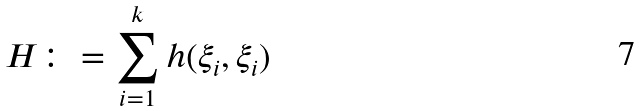<formula> <loc_0><loc_0><loc_500><loc_500>H \colon = \sum _ { i = 1 } ^ { k } h ( \xi _ { i } , \xi _ { i } )</formula> 